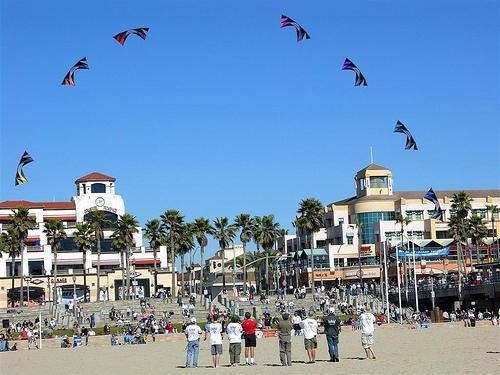The items the people are staring at are likely made of what? fabric 